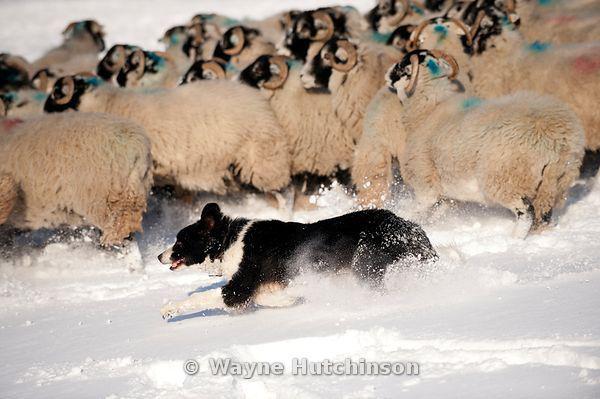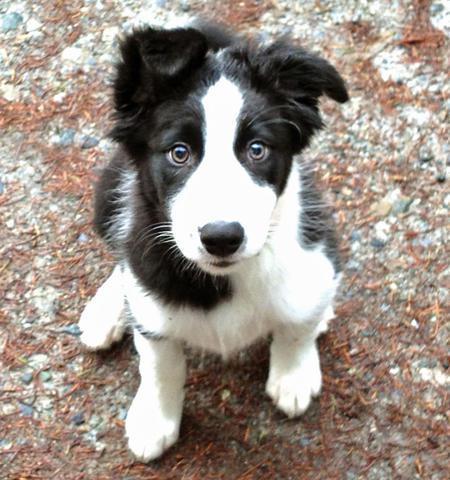The first image is the image on the left, the second image is the image on the right. Considering the images on both sides, is "Right image contains one dog sitting up." valid? Answer yes or no. Yes. The first image is the image on the left, the second image is the image on the right. For the images shown, is this caption "In one image, a black and white dog is outdoors with sheep." true? Answer yes or no. Yes. 